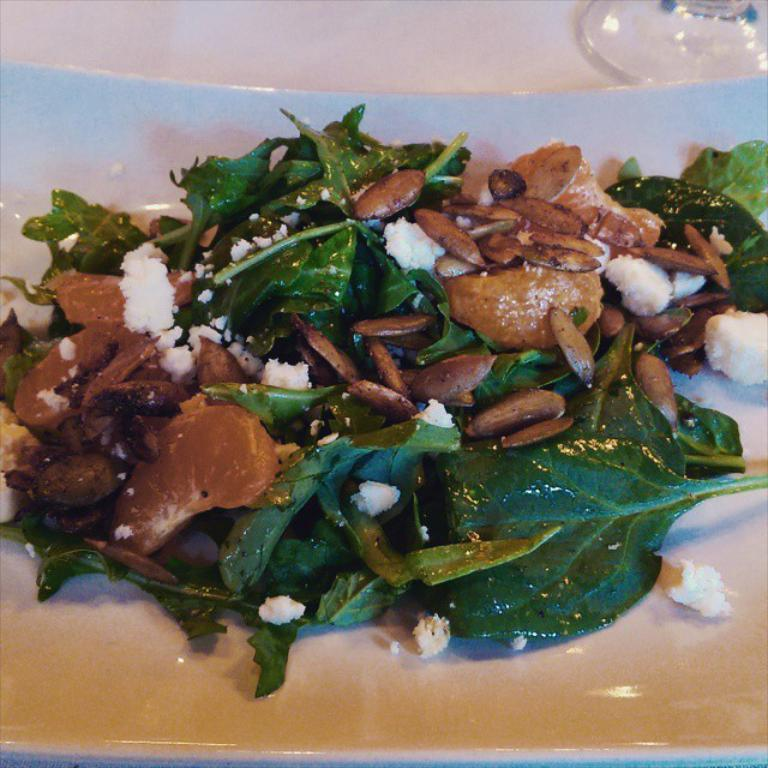What is placed on the white color plate in the image? There are leaves, seeds, and other food items on a white color plate in the image. Where is the plate located? The plate is placed on a table. What is the color of the background in the image? The background of the image is white in color. What type of wood can be seen in the image? There is no wood present in the image. Is there a door visible in the image? No, there is no door visible in the image. 